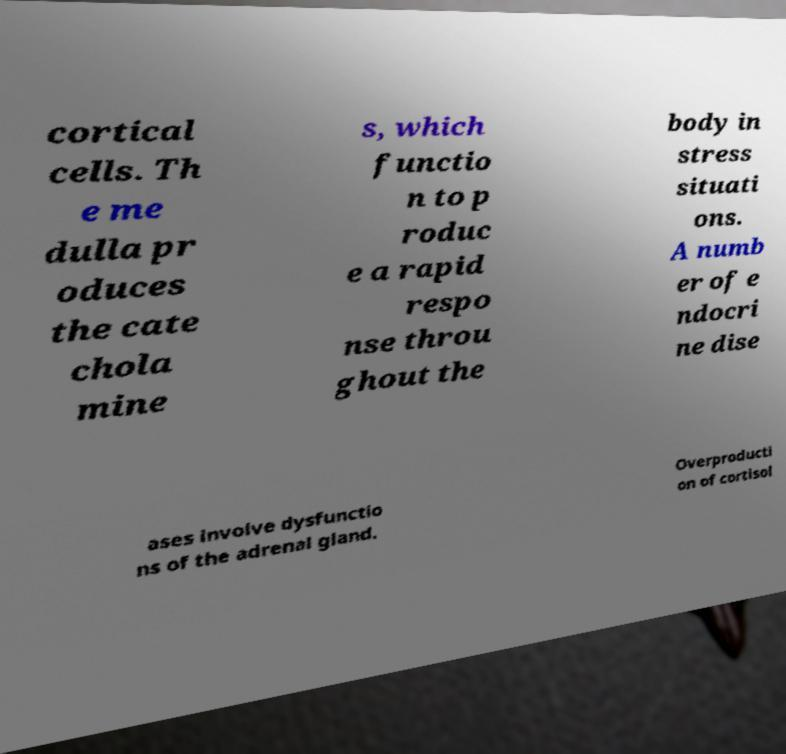Could you assist in decoding the text presented in this image and type it out clearly? cortical cells. Th e me dulla pr oduces the cate chola mine s, which functio n to p roduc e a rapid respo nse throu ghout the body in stress situati ons. A numb er of e ndocri ne dise ases involve dysfunctio ns of the adrenal gland. Overproducti on of cortisol 